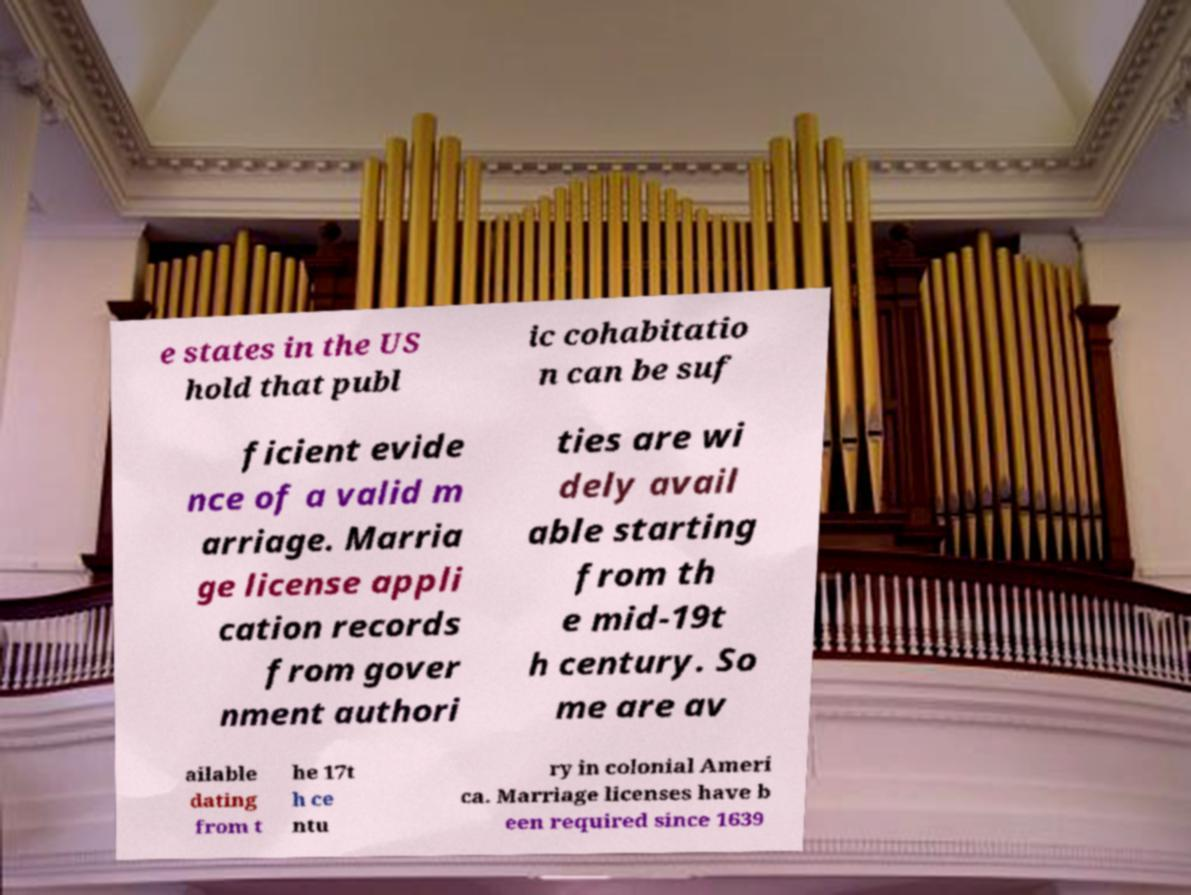Could you assist in decoding the text presented in this image and type it out clearly? e states in the US hold that publ ic cohabitatio n can be suf ficient evide nce of a valid m arriage. Marria ge license appli cation records from gover nment authori ties are wi dely avail able starting from th e mid-19t h century. So me are av ailable dating from t he 17t h ce ntu ry in colonial Ameri ca. Marriage licenses have b een required since 1639 